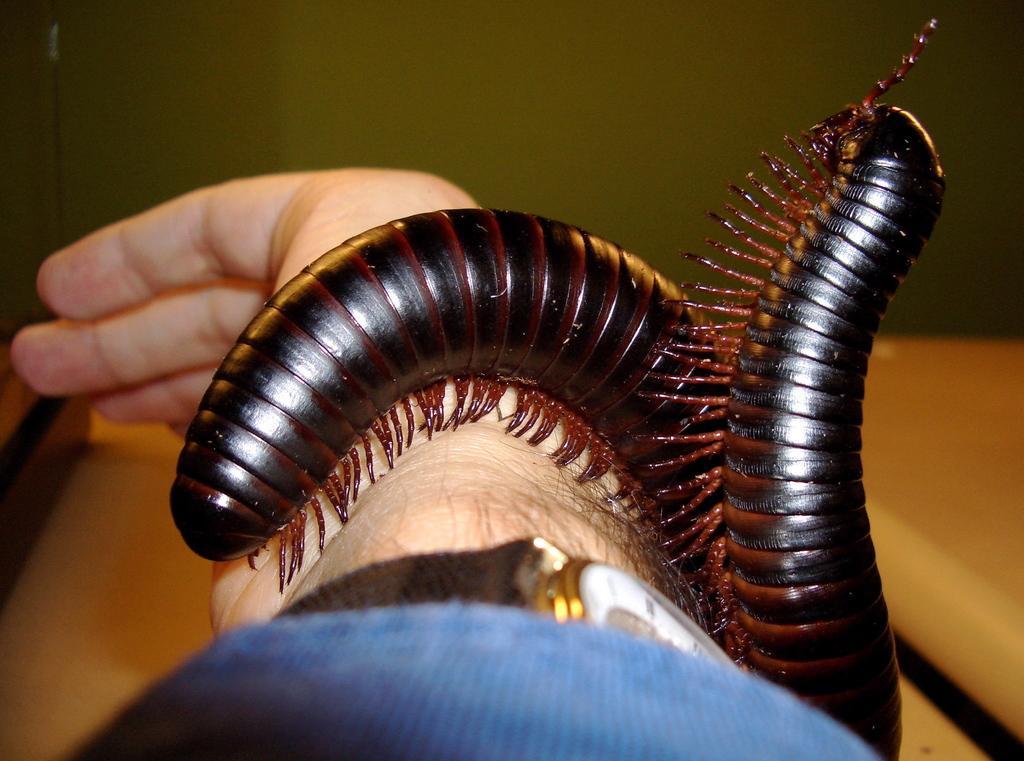In one or two sentences, can you explain what this image depicts? In the image we can see a hand, on the hand there are some insects. Background of the image is blur. 